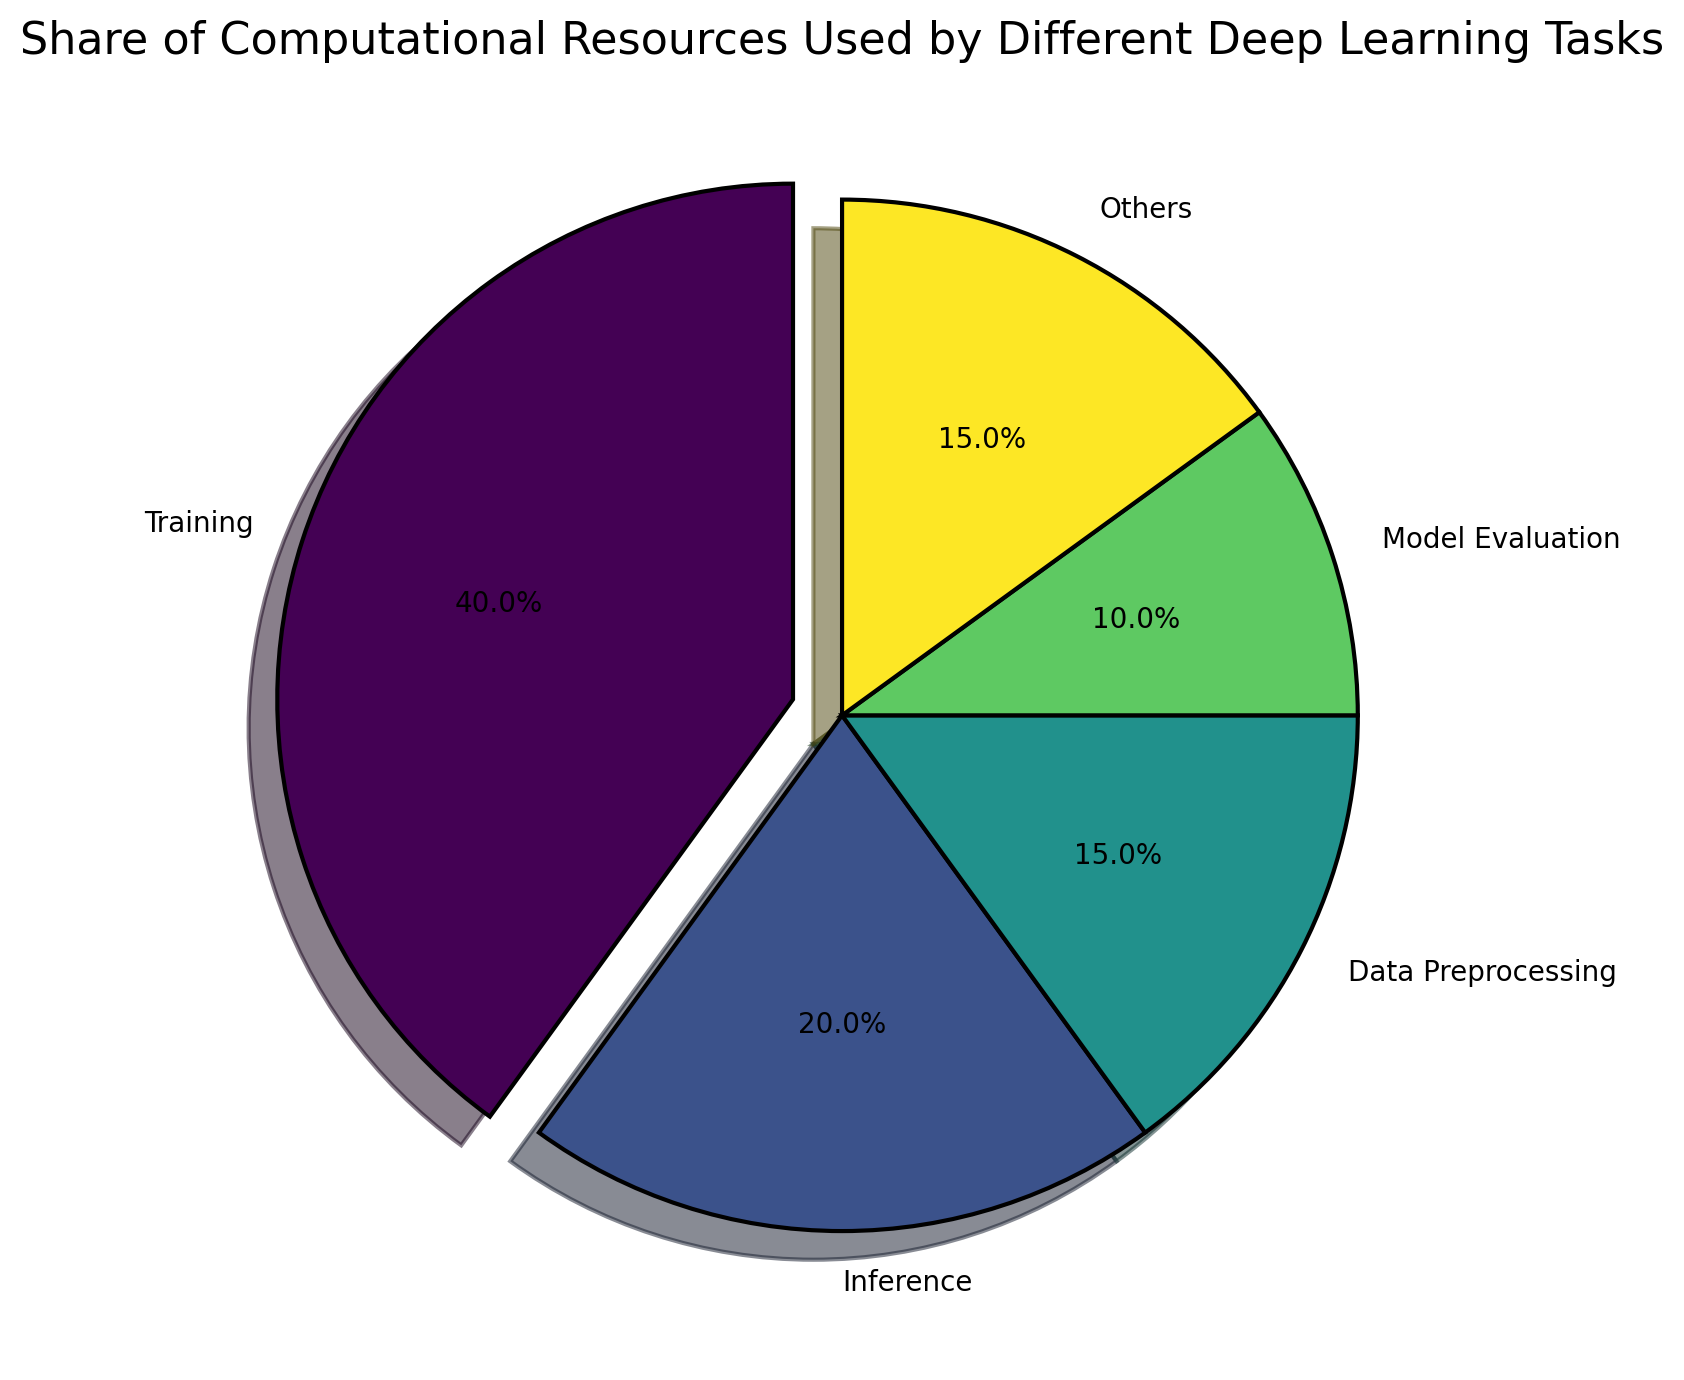What tasks are included in the pie chart? The pie chart includes the following tasks: Training, Inference, Data Preprocessing, Model Evaluation, and Others. This can be seen from the labels on each slice of the pie chart.
Answer: Training, Inference, Data Preprocessing, Model Evaluation, Others Which task uses the most computational resources? The task that uses the most computational resources is represented by the largest slice of the pie chart, which is labeled "Training".
Answer: Training What is the total share of computational resources used by Data Preprocessing and Others combined? To find the total share of computational resources used by Data Preprocessing and Others, add their shares together: 15% (Data Preprocessing) + 15% (Others) = 30%.
Answer: 30% How does the share of computational resources for Inference compare with that for Model Evaluation? The pie chart shows that Inference has a share of 20% and Model Evaluation has a share of 10%. Inference uses more computational resources than Model Evaluation.
Answer: Inference uses more If you combine Training and Inference, what percentage of the total computational resources do they use? Add the shares of Training and Inference: 40% (Training) + 20% (Inference) = 60%.
Answer: 60% What is the color assigned to the Data Preprocessing slice? The Data Preprocessing slice of the pie chart is colored based on one of the colors from the viridis colormap. The middle section of the colormap typically corresponds to a shade of green.
Answer: Green What is the difference in the share of computational resources between the largest and smallest tasks? The largest task is Training with 40%, and the smallest task is Model Evaluation with 10%. The difference is 40% - 10% = 30%.
Answer: 30% Which tasks have equal shares of computational resources? According to the pie chart, Data Preprocessing and Others both use 15% of the computational resources.
Answer: Data Preprocessing and Others How much more computational resources does Training need compared to Inference? Training uses 40% of the resources, while Inference uses 20%. The difference is 40% - 20% = 20%.
Answer: 20% 